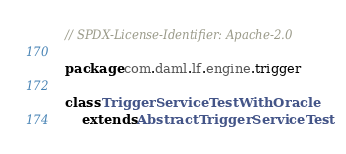Convert code to text. <code><loc_0><loc_0><loc_500><loc_500><_Scala_>// SPDX-License-Identifier: Apache-2.0

package com.daml.lf.engine.trigger

class TriggerServiceTestWithOracle
    extends AbstractTriggerServiceTest</code> 